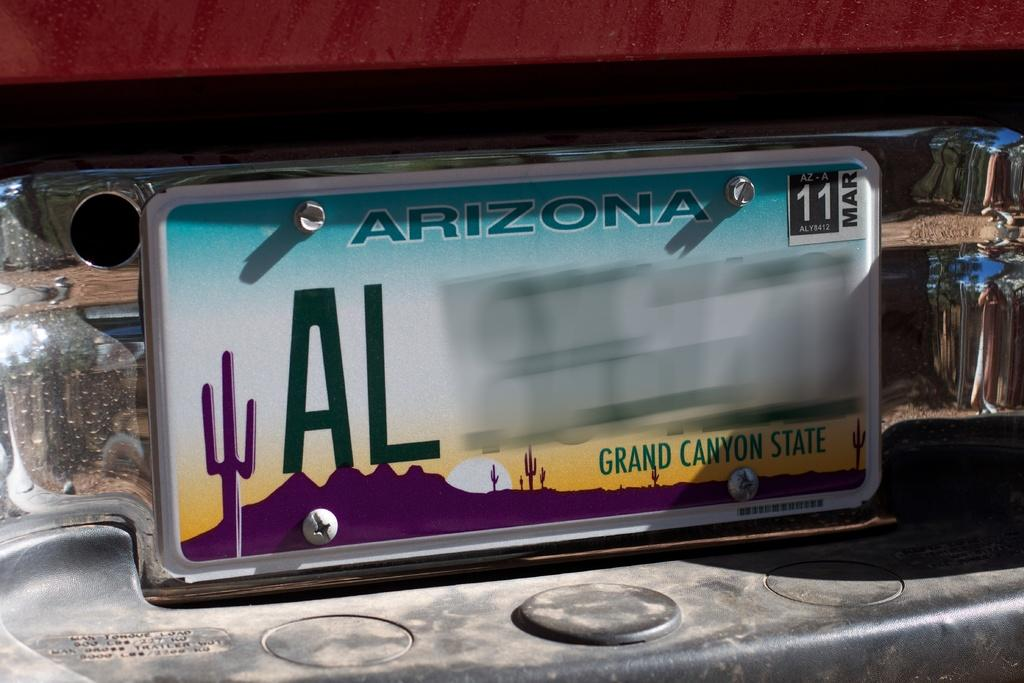<image>
Provide a brief description of the given image. The license plate is from the city of Arizona. 